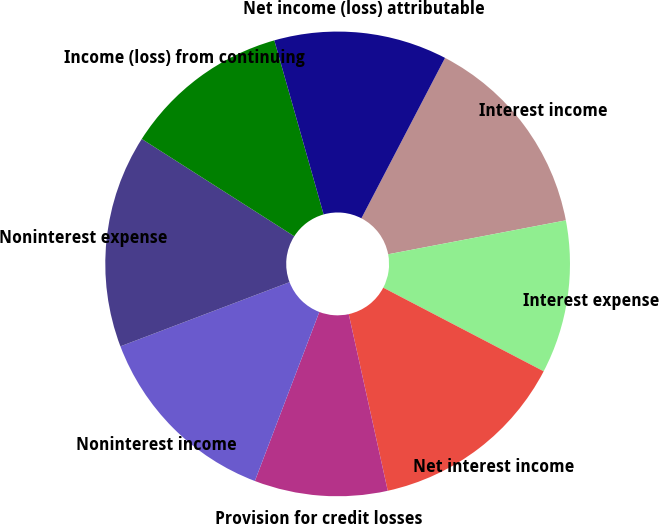Convert chart to OTSL. <chart><loc_0><loc_0><loc_500><loc_500><pie_chart><fcel>Interest income<fcel>Interest expense<fcel>Net interest income<fcel>Provision for credit losses<fcel>Noninterest income<fcel>Noninterest expense<fcel>Income (loss) from continuing<fcel>Net income (loss) attributable<nl><fcel>14.35%<fcel>10.65%<fcel>13.89%<fcel>9.26%<fcel>13.43%<fcel>14.81%<fcel>11.57%<fcel>12.04%<nl></chart> 